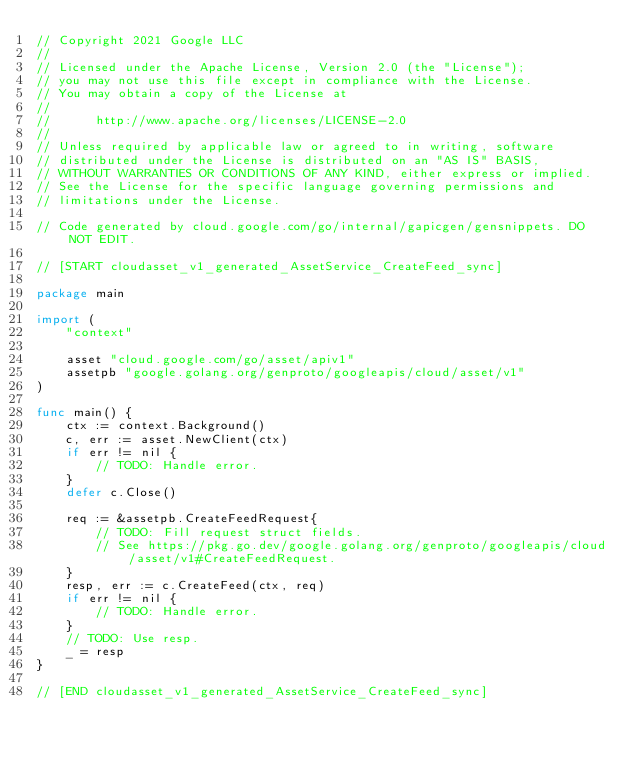Convert code to text. <code><loc_0><loc_0><loc_500><loc_500><_Go_>// Copyright 2021 Google LLC
//
// Licensed under the Apache License, Version 2.0 (the "License");
// you may not use this file except in compliance with the License.
// You may obtain a copy of the License at
//
//      http://www.apache.org/licenses/LICENSE-2.0
//
// Unless required by applicable law or agreed to in writing, software
// distributed under the License is distributed on an "AS IS" BASIS,
// WITHOUT WARRANTIES OR CONDITIONS OF ANY KIND, either express or implied.
// See the License for the specific language governing permissions and
// limitations under the License.

// Code generated by cloud.google.com/go/internal/gapicgen/gensnippets. DO NOT EDIT.

// [START cloudasset_v1_generated_AssetService_CreateFeed_sync]

package main

import (
	"context"

	asset "cloud.google.com/go/asset/apiv1"
	assetpb "google.golang.org/genproto/googleapis/cloud/asset/v1"
)

func main() {
	ctx := context.Background()
	c, err := asset.NewClient(ctx)
	if err != nil {
		// TODO: Handle error.
	}
	defer c.Close()

	req := &assetpb.CreateFeedRequest{
		// TODO: Fill request struct fields.
		// See https://pkg.go.dev/google.golang.org/genproto/googleapis/cloud/asset/v1#CreateFeedRequest.
	}
	resp, err := c.CreateFeed(ctx, req)
	if err != nil {
		// TODO: Handle error.
	}
	// TODO: Use resp.
	_ = resp
}

// [END cloudasset_v1_generated_AssetService_CreateFeed_sync]
</code> 